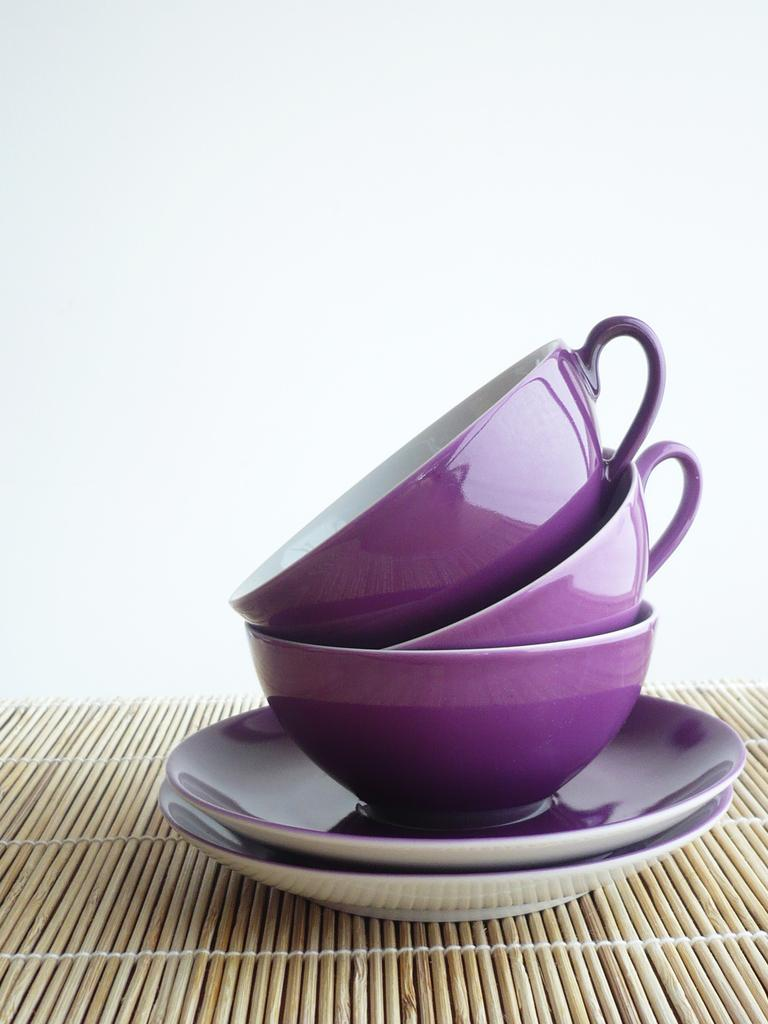What color are the cups in the image? The cups in the image are purple. What other items in the image match the color of the cups? There are purple saucers in the image. What color is the background of the image? The background of the image is white. How many girls are holding the purple cups in the image? There are no girls present in the image; it only features purple cups and saucers against a white background. 